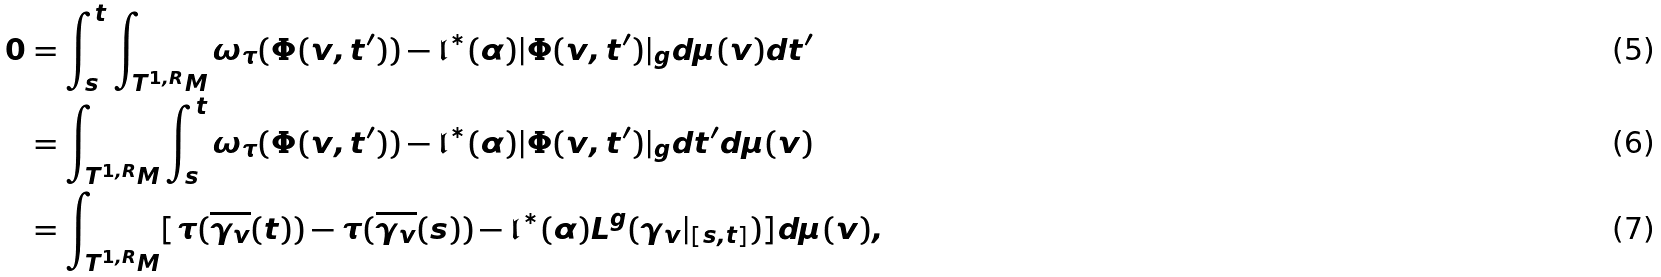Convert formula to latex. <formula><loc_0><loc_0><loc_500><loc_500>0 & = \int _ { s } ^ { t } \int _ { T ^ { 1 , R } M } \omega _ { \tau } ( \Phi ( v , t ^ { \prime } ) ) - \mathfrak { l } ^ { \ast } ( \alpha ) | \Phi ( v , t ^ { \prime } ) | _ { g } d \mu ( v ) d t ^ { \prime } \\ & = \int _ { T ^ { 1 , R } M } \int _ { s } ^ { t } \omega _ { \tau } ( \Phi ( v , t ^ { \prime } ) ) - \mathfrak { l } ^ { \ast } ( \alpha ) | \Phi ( v , t ^ { \prime } ) | _ { g } d t ^ { \prime } d \mu ( v ) \\ & = \int _ { T ^ { 1 , R } M } [ \tau ( \overline { \gamma _ { v } } ( t ) ) - \tau ( \overline { \gamma _ { v } } ( s ) ) - \mathfrak { l } ^ { \ast } ( \alpha ) L ^ { g } ( \gamma _ { v } | _ { [ s , t ] } ) ] d \mu ( v ) ,</formula> 